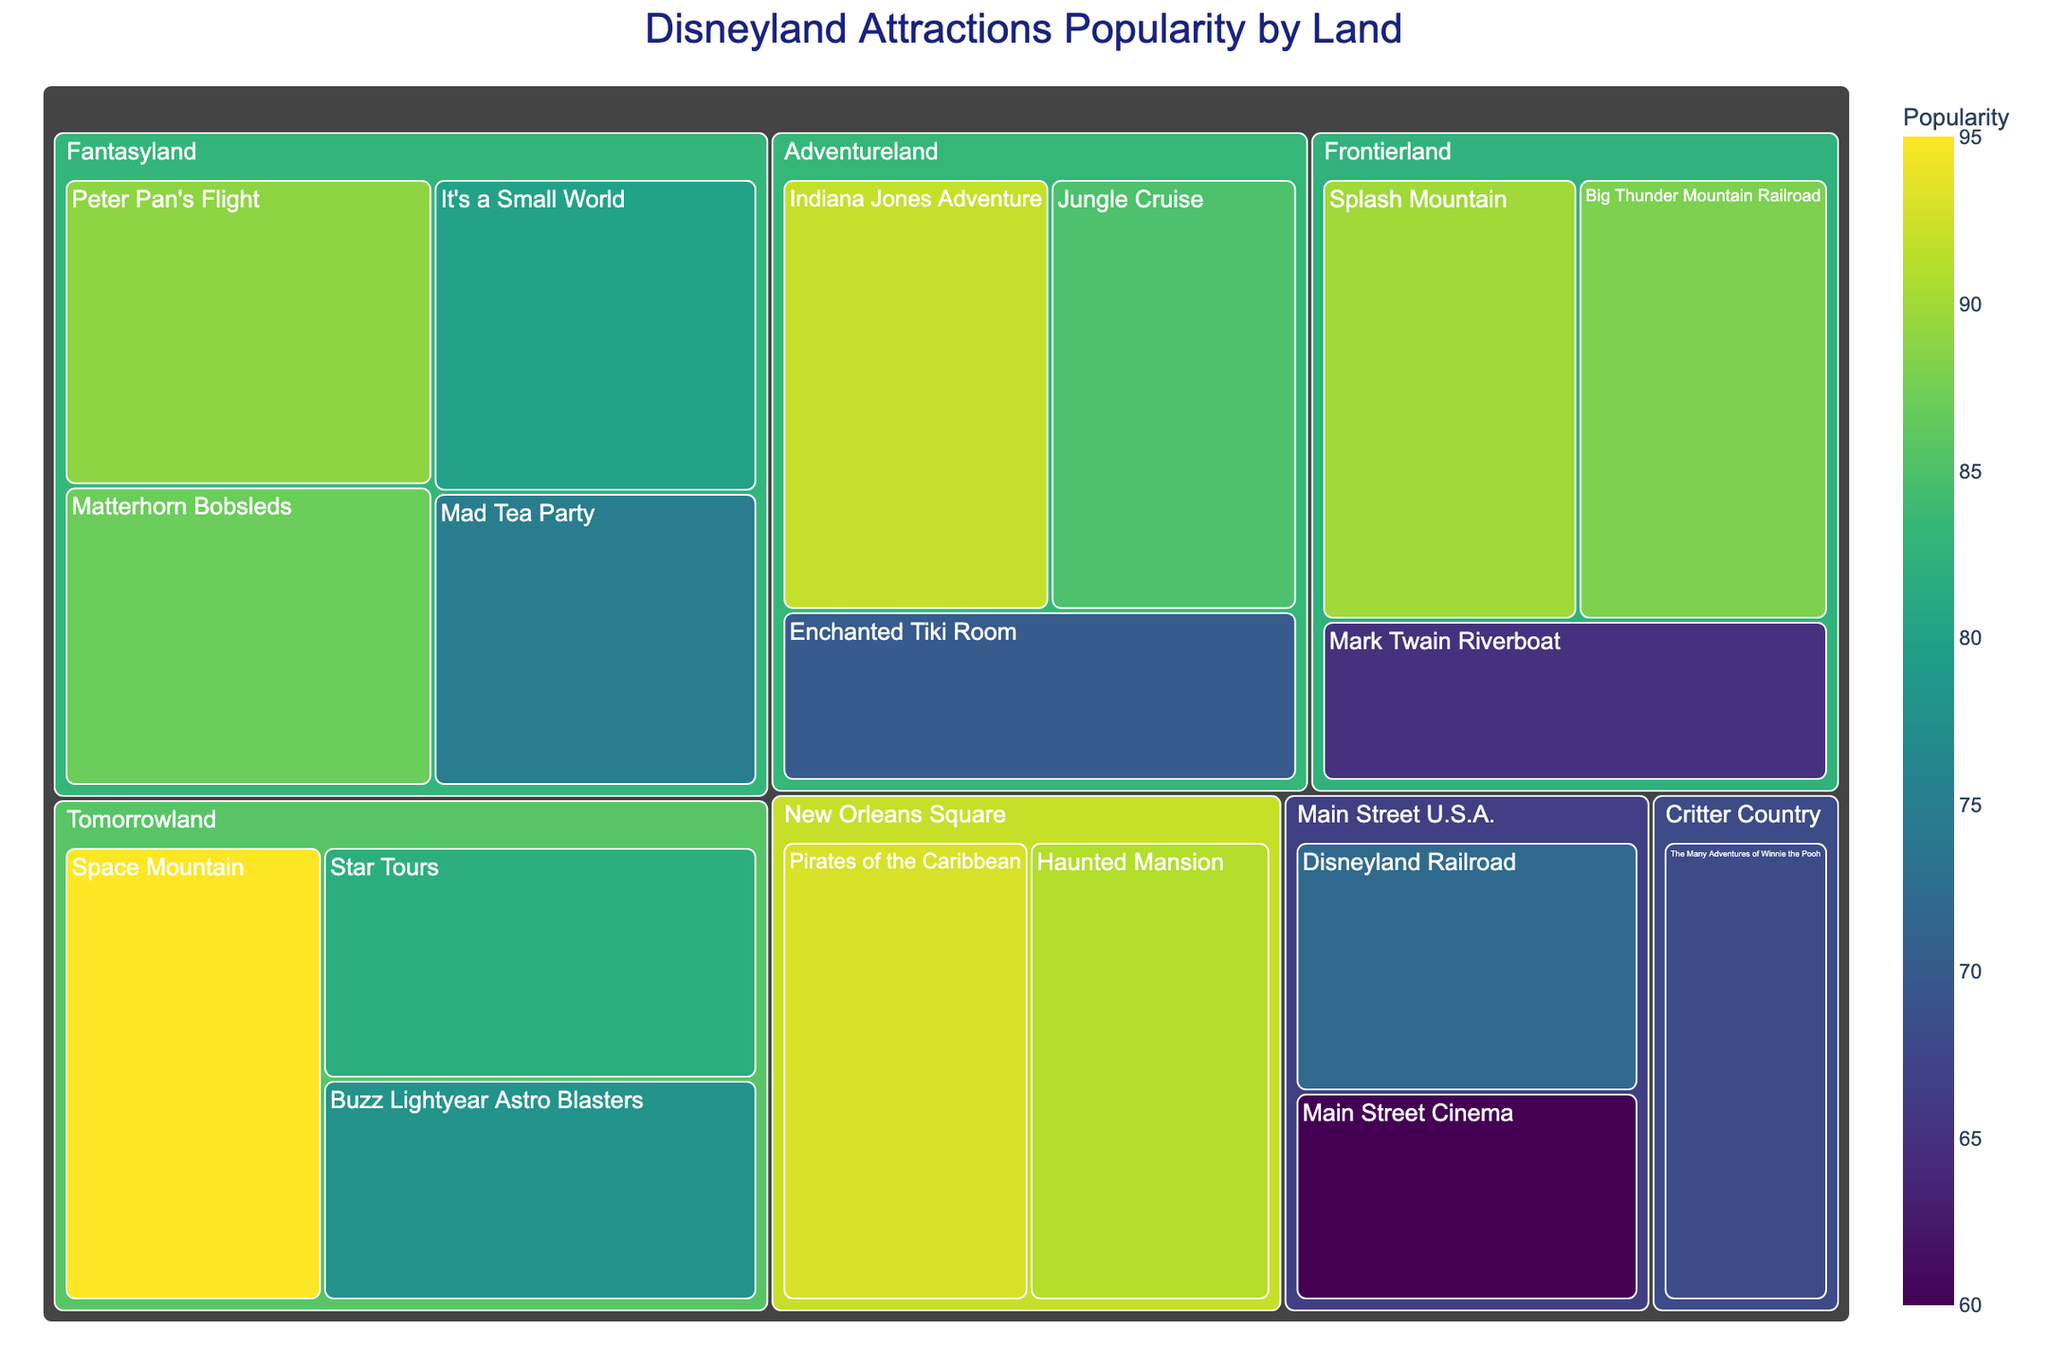Which land has the most popular attraction? To determine this, identify the attraction with the highest popularity score. Then, find out which land it belongs to. The most popular attraction is Space Mountain with a popularity score of 95, which is located in Tomorrowland.
Answer: Tomorrowland What is the least popular attraction in Main Street U.S.A.? Identify the attractions in Main Street U.S.A. and then check their popularity scores. The least popular attraction in Main Street U.S.A. is Main Street Cinema with a score of 60.
Answer: Main Street Cinema Which land has the highest average popularity of its attractions? Calculate the average popularity for each land by summing the popularity scores and dividing by the number of attractions in that land. The averages are: Adventureland (82.33), Frontierland (81), Fantasyland (82.75), Tomorrowland (85), Main Street U.S.A. (66), Critter Country (68), New Orleans Square (92). New Orleans Square has the highest average popularity.
Answer: New Orleans Square How many attractions in the plot have a popularity score higher than 80? Count the number of attractions with a popularity score greater than 80 in the treemap. The attractions with scores above 80 are: Jungle Cruise, Indiana Jones Adventure, Big Thunder Mountain Railroad, Splash Mountain, Peter Pan's Flight, Matterhorn Bobsleds, Space Mountain, Star Tours, Pirates of the Caribbean, and Haunted Mansion. There are 10 attractions.
Answer: 10 Which attraction in Fantasyland is the least popular? Identify the attractions in Fantasyland and compare their popularity scores. The least popular attraction in Fantasyland is Mad Tea Party with a score of 75.
Answer: Mad Tea Party What is the total popularity score for attractions in Adventureland? Sum the popularity scores of all attractions in Adventureland: Jungle Cruise (85), Indiana Jones Adventure (92), and Enchanted Tiki Room (70). The total is 85 + 92 + 70 = 247.
Answer: 247 Which attraction has a higher popularity: Jungle Cruise or Haunted Mansion? Compare the popularity scores of Jungle Cruise and Haunted Mansion. Jungle Cruise has a score of 85, while Haunted Mansion has a score of 91. Haunted Mansion is more popular.
Answer: Haunted Mansion What is the total number of attractions shown in the plot? Count all attractions listed in the treemap. There are 17 attractions in total.
Answer: 17 What is the difference in popularity between Space Mountain and Buzz Lightyear Astro Blasters? Subtract the popularity score of Buzz Lightyear Astro Blasters (78) from the popularity score of Space Mountain (95): 95 - 78 = 17.
Answer: 17 What color represents the highest popularity score and which attraction does it belong to? The color representing the highest popularity score is the brightest (most intense) on the Viridis color scale. The highest popularity score is 95, and it belongs to Space Mountain.
Answer: Bright green, Space Mountain 